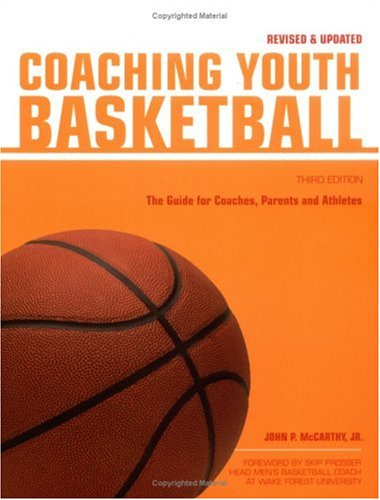Who is the author of this book? The author of the book, as clearly displayed on the cover, is John M. McCarthy Jr. 